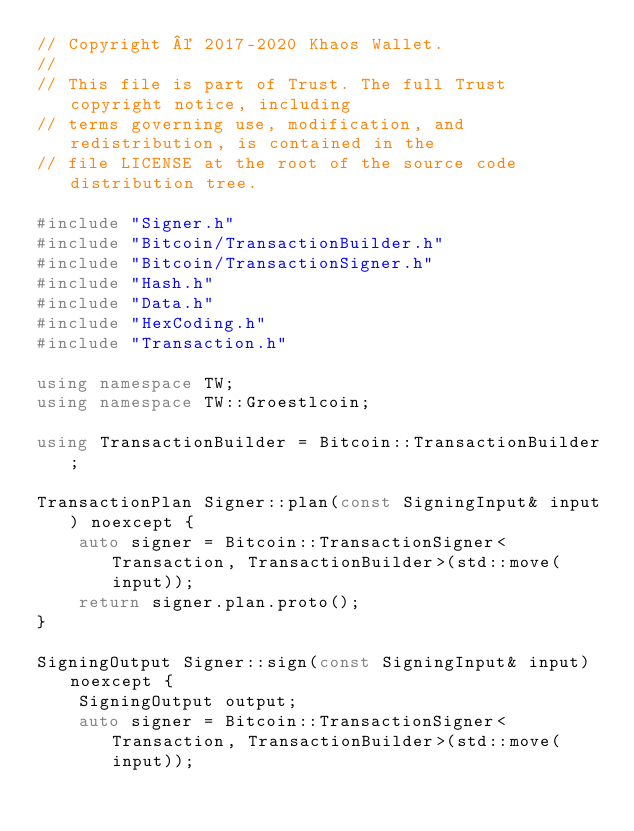Convert code to text. <code><loc_0><loc_0><loc_500><loc_500><_C++_>// Copyright © 2017-2020 Khaos Wallet.
//
// This file is part of Trust. The full Trust copyright notice, including
// terms governing use, modification, and redistribution, is contained in the
// file LICENSE at the root of the source code distribution tree.

#include "Signer.h"
#include "Bitcoin/TransactionBuilder.h"
#include "Bitcoin/TransactionSigner.h"
#include "Hash.h"
#include "Data.h"
#include "HexCoding.h"
#include "Transaction.h"

using namespace TW;
using namespace TW::Groestlcoin;

using TransactionBuilder = Bitcoin::TransactionBuilder;

TransactionPlan Signer::plan(const SigningInput& input) noexcept {
    auto signer = Bitcoin::TransactionSigner<Transaction, TransactionBuilder>(std::move(input));
    return signer.plan.proto();
}

SigningOutput Signer::sign(const SigningInput& input) noexcept {
    SigningOutput output;
    auto signer = Bitcoin::TransactionSigner<Transaction, TransactionBuilder>(std::move(input));</code> 